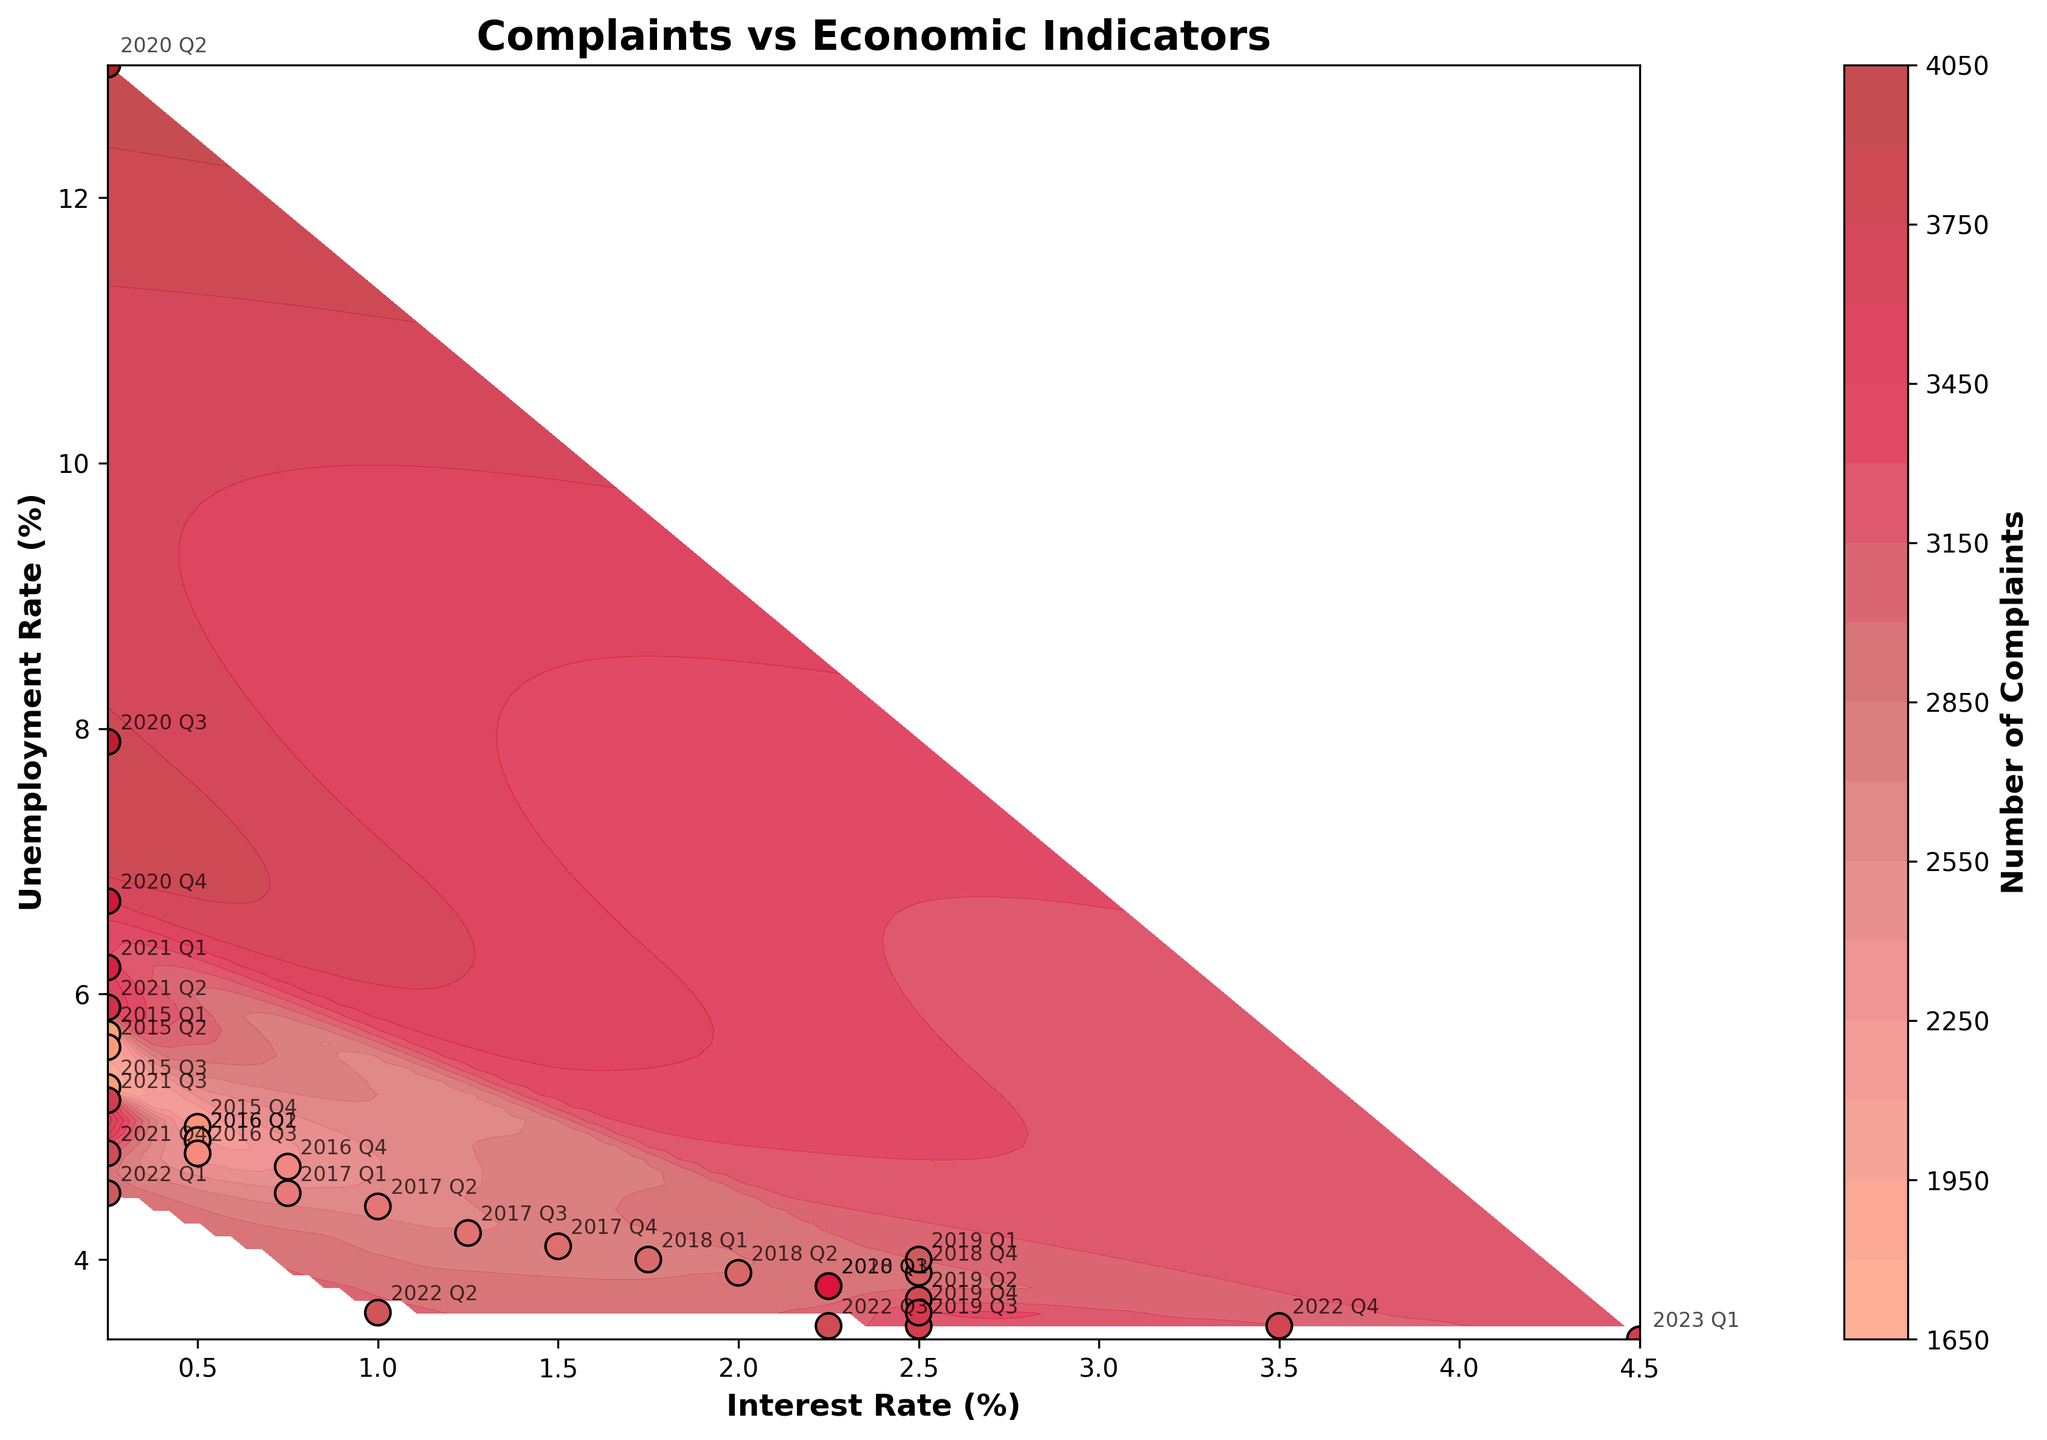What is the title of the plot? The title of the plot is displayed at the top and indicates what the plot is about. By looking at the title, you can understand the general topic of the plot.
Answer: Complaints vs Economic Indicators How many levels are there in the contour plot? The levels in a contour plot represent different ranges of the z-value (in this case, the number of complaints). You can count these levels by looking at the different shades of color in the contour plot. Usually, each distinct color represents a level.
Answer: 20 Which year had the highest number of complaints? The data points on the plot are color-coded, with the colorbar providing the key to the number of complaints represented by each color. By finding the point with the darkest color within the color range for complaints, you can identify the period with the highest number of complaints.
Answer: 2020 Q2 What is the relationship between interest rate and the number of complaints in 2020 Q2? Locate 2020 Q2 on the plot and observe the interest rate value from the x-axis. Then refer to the color of this data point to determine the number of complaints.
Answer: As the interest rate significantly dropped, the number of complaints peaked Do higher unemployment rates generally correlate with a higher number of complaints? Observe the correlation between the unemployment rate (y-axis) and the contour shades representing the number of complaints. Note if data points with higher unemployment rates tend towards darker colors (more complaints).
Answer: Yes, generally higher unemployment rates correlate with more complaints How does the number of complaints change as the interest rate increases from 2015 to 2023? Follow the change in interest rate values along the x-axis from 2015 to 2023 and use the color shades to identify the change in the number of complaints over this period.
Answer: Generally increases, especially towards 2020 Q2 and gradually decreasing thereafter Compare the number of complaints in 2019 Q4 to 2020 Q1. Identify 2019 Q4 and 2020 Q1 on the plot using their annotations and compare the specific colors of these points to determine which has a higher number of complaints.
Answer: 2020 Q1 had more complaints than 2019 Q4 What pattern do you observe in the number of complaints during a significant economic disruption like in 2020? Check the data points for 2020, specifically before, during, and after significant changes in economic indicators (sharp rise in unemployment, drop in interest rate) to see how complaints are affected.
Answer: There is a sharp increase in the number of complaints during the economic disruption What was the trend in the unemployment rate from 2015 to 2023 and how did it impact the number of complaints? Observe the data points along the y-axis for the period from 2015 to 2023, noting the change in unemployment rates, and correlate this with the color of the data points and contour shades to determine the trend in complaints.
Answer: Unemployment rate generally decreased until 2020, where it spiked, causing a rise in complaints. Thereafter, it decreased again, lowering complaints Explain the significance of the custom colormap in the plot. The custom colormap provides a visual gradient that represents the density or intensity of complaints. Each color in the gradient corresponds to a range of complaint values as indicated by the colorbar. This helps in visualizing the distribution and intensity of the complaints across different economic conditions.
Answer: It helps visualize complaint intensity 